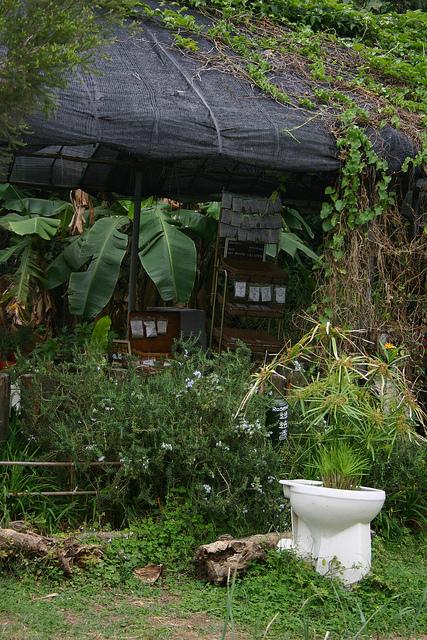How many flowers are in the bushes?
Short answer required. 15. Is that a banana tree in the back?
Short answer required. Yes. Is this toilet operational?
Be succinct. No. 